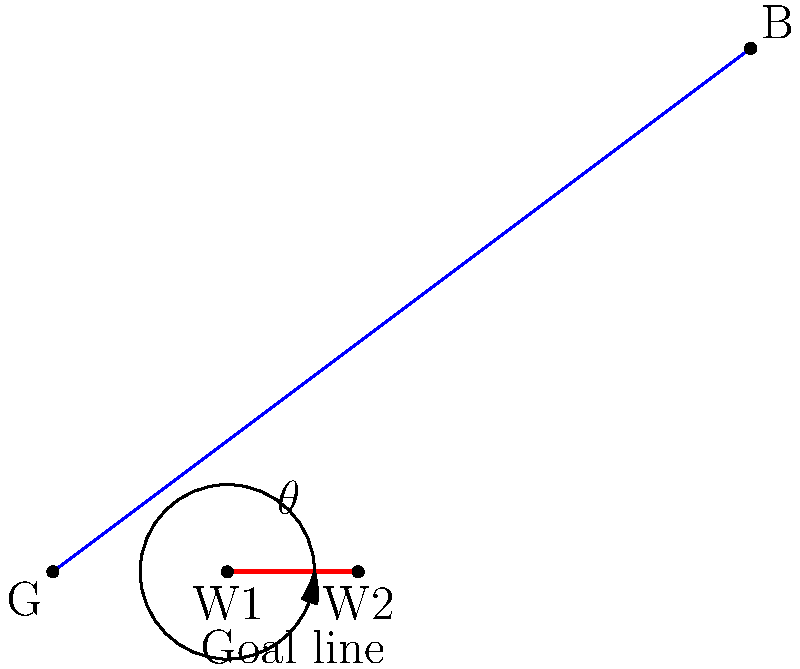In a free kick situation, the ball (B) is positioned 100 units away from the center of the goal (G) at coordinates (80, 60). The defensive wall is placed 20 units in front of the goal line, spanning from point W1 (20, 0) to W2 (35, 0). What is the optimal angle $\theta$ (in degrees) that the defensive wall should form with the goal line to best block the free kick? To find the optimal angle for the defensive wall, we need to follow these steps:

1) First, we need to find the vector from the center of the wall to the ball. 
   The center of the wall is at $(\frac{20+35}{2}, 0) = (27.5, 0)$.
   Vector to the ball: $(80-27.5, 60-0) = (52.5, 60)$

2) The optimal angle is perpendicular to this vector. We can find it using the arctangent function:

   $\theta = \arctan(\frac{52.5}{60})$

3) Convert radians to degrees:

   $\theta = \arctan(\frac{52.5}{60}) \cdot \frac{180}{\pi}$

4) Calculate the result:

   $\theta \approx 41.19°$

5) The angle we calculated is with respect to the vertical. To get the angle with the goal line, we need to subtract it from 90°:

   $90° - 41.19° \approx 48.81°$

Therefore, the optimal angle for the defensive wall is approximately 48.81° with respect to the goal line.
Answer: 48.81° 